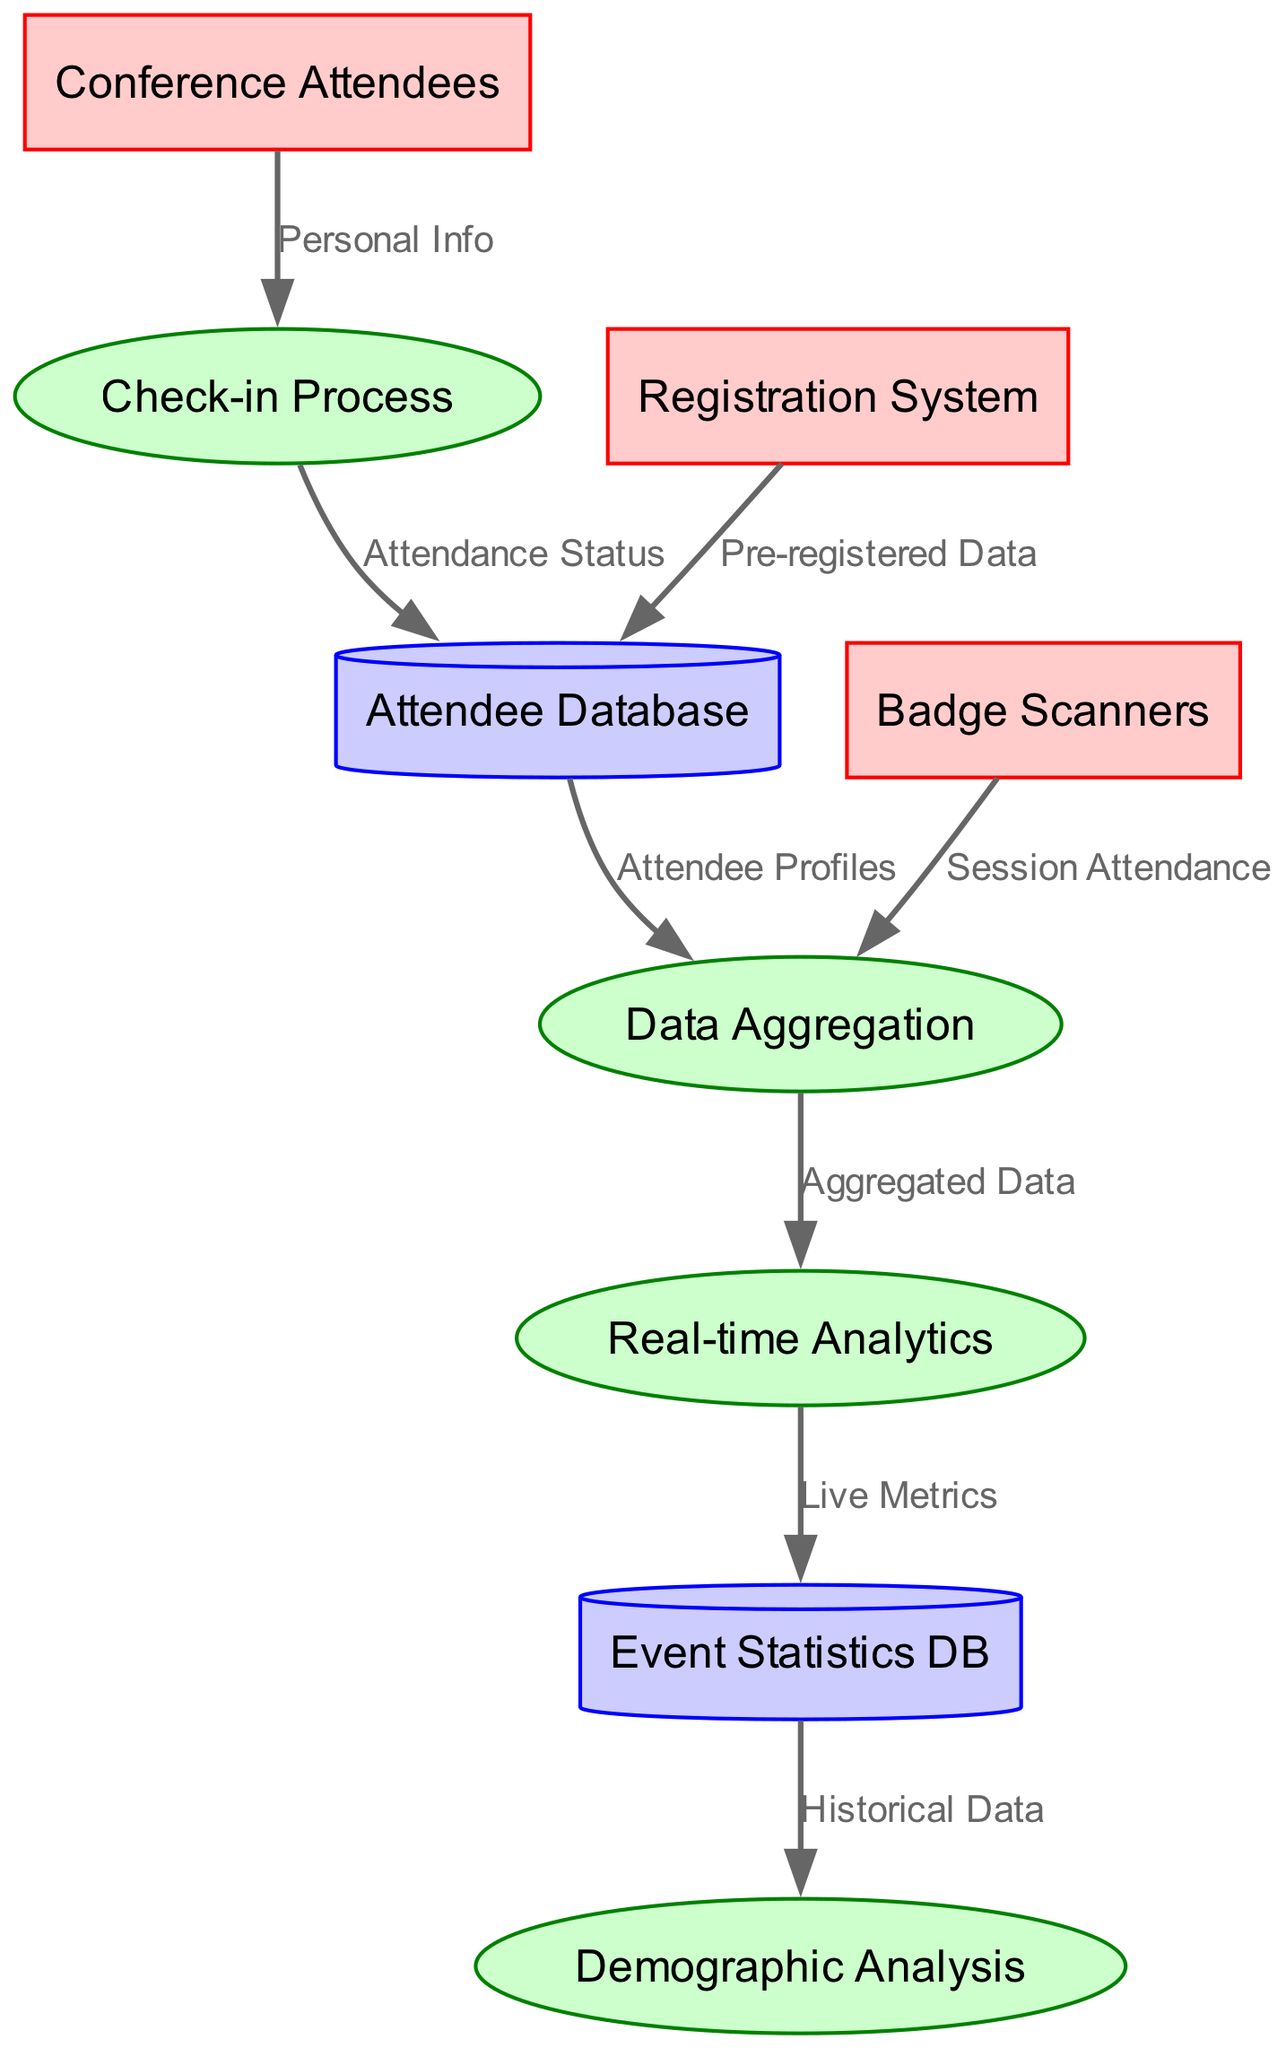What are the external entities in this diagram? The external entities are the actors or stakeholders that interact with the system represented in the diagram. In this case, they include "Conference Attendees," "Registration System," and "Badge Scanners."
Answer: Conference Attendees, Registration System, Badge Scanners How many processes are depicted in the diagram? The processes are the activities or functions performed by the system depicted in the diagram. Here, there are four processes: "Check-in Process," "Data Aggregation," "Real-time Analytics," and "Demographic Analysis." Counting them gives a total of four processes.
Answer: 4 What type of data flows from the "Badge Scanners" to "Data Aggregation"? Data flows are the pathways through which information moves between nodes in the diagram. In this case, the specific flow from "Badge Scanners" to "Data Aggregation" carries "Session Attendance."
Answer: Session Attendance Which data store receives "Pre-registered Data"? By analyzing the data flows, the "Pre-registered Data" comes from the "Registration System" and is directed to the "Attendee Database." This indicates that the "Attendee Database" is where this data is stored.
Answer: Attendee Database What kind of data does "Real-time Analytics" send to the "Event Statistics DB"? Data flows signify the type of information being transferred. The flow from "Real-time Analytics" to "Event Statistics DB" transfers "Live Metrics," which represents real-time data analytics results.
Answer: Live Metrics What is the relationship between "Check-in Process" and "Attendee Database"? This relationship is depicted as a data flow that indicates data movement. The "Check-in Process" sends "Attendance Status" to the "Attendee Database," informing the database of who has attended the event.
Answer: Attendance Status How does the "Demographic Analysis" receive input data? To understand how input data flows into demographic analysis, we can trace the data paths. The "Demographic Analysis" receives input from the "Event Statistics DB," which is populated using "Historical Data." This data represents previous attendee demographics and statistics.
Answer: Historical Data Which external entity provides "Personal Info"? External entities represent sources of information in the diagram. The "Conference Attendees" are the external entity that provides "Personal Info" during the check-in process.
Answer: Conference Attendees What process directly follows "Data Aggregation"? By following the directional flow of the processes, after "Data Aggregation," the next process is "Real-time Analytics," demonstrating the sequential steps in the analysis of collected data.
Answer: Real-time Analytics 